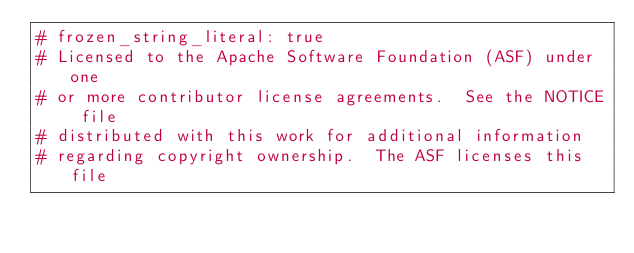Convert code to text. <code><loc_0><loc_0><loc_500><loc_500><_Ruby_># frozen_string_literal: true
# Licensed to the Apache Software Foundation (ASF) under one
# or more contributor license agreements.  See the NOTICE file
# distributed with this work for additional information
# regarding copyright ownership.  The ASF licenses this file</code> 